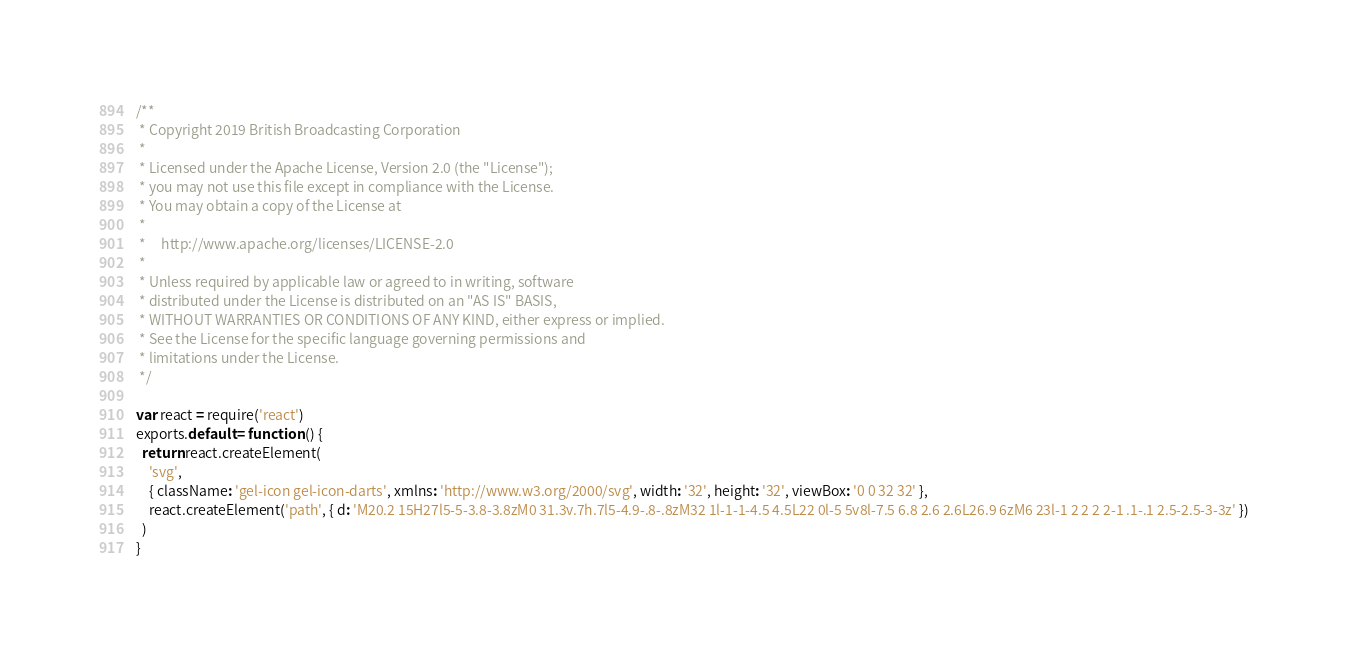Convert code to text. <code><loc_0><loc_0><loc_500><loc_500><_JavaScript_>/**
 * Copyright 2019 British Broadcasting Corporation
 *
 * Licensed under the Apache License, Version 2.0 (the "License");
 * you may not use this file except in compliance with the License.
 * You may obtain a copy of the License at
 *
 *     http://www.apache.org/licenses/LICENSE-2.0
 *
 * Unless required by applicable law or agreed to in writing, software
 * distributed under the License is distributed on an "AS IS" BASIS,
 * WITHOUT WARRANTIES OR CONDITIONS OF ANY KIND, either express or implied.
 * See the License for the specific language governing permissions and
 * limitations under the License.
 */

var react = require('react')
exports.default = function () {
  return react.createElement(
    'svg',
    { className: 'gel-icon gel-icon-darts', xmlns: 'http://www.w3.org/2000/svg', width: '32', height: '32', viewBox: '0 0 32 32' },
    react.createElement('path', { d: 'M20.2 15H27l5-5-3.8-3.8zM0 31.3v.7h.7l5-4.9-.8-.8zM32 1l-1-1-4.5 4.5L22 0l-5 5v8l-7.5 6.8 2.6 2.6L26.9 6zM6 23l-1 2 2 2 2-1 .1-.1 2.5-2.5-3-3z' })
  )
}
</code> 